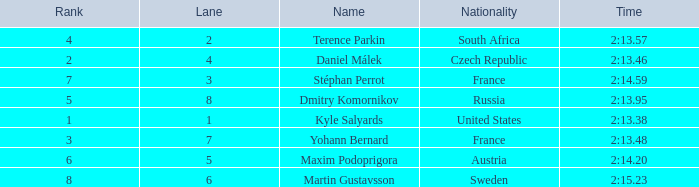What was Stéphan Perrot rank average? 7.0. 